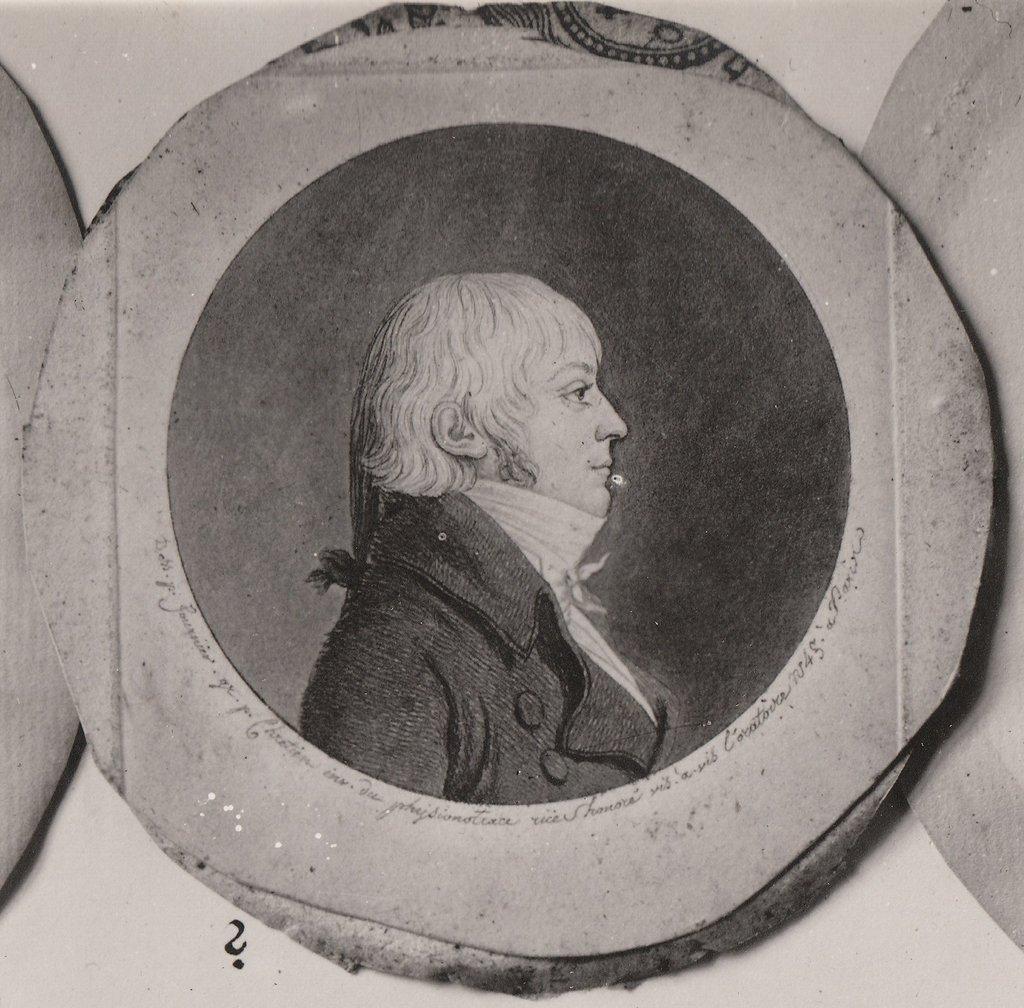How would you summarize this image in a sentence or two? This is a black and white picture. In this picture, we see a man. It looks like a photo frame which is placed on the white wall. 